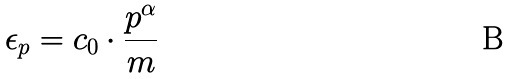<formula> <loc_0><loc_0><loc_500><loc_500>\epsilon _ { p } = c _ { 0 } \cdot \frac { { p } ^ { \alpha } } { m }</formula> 